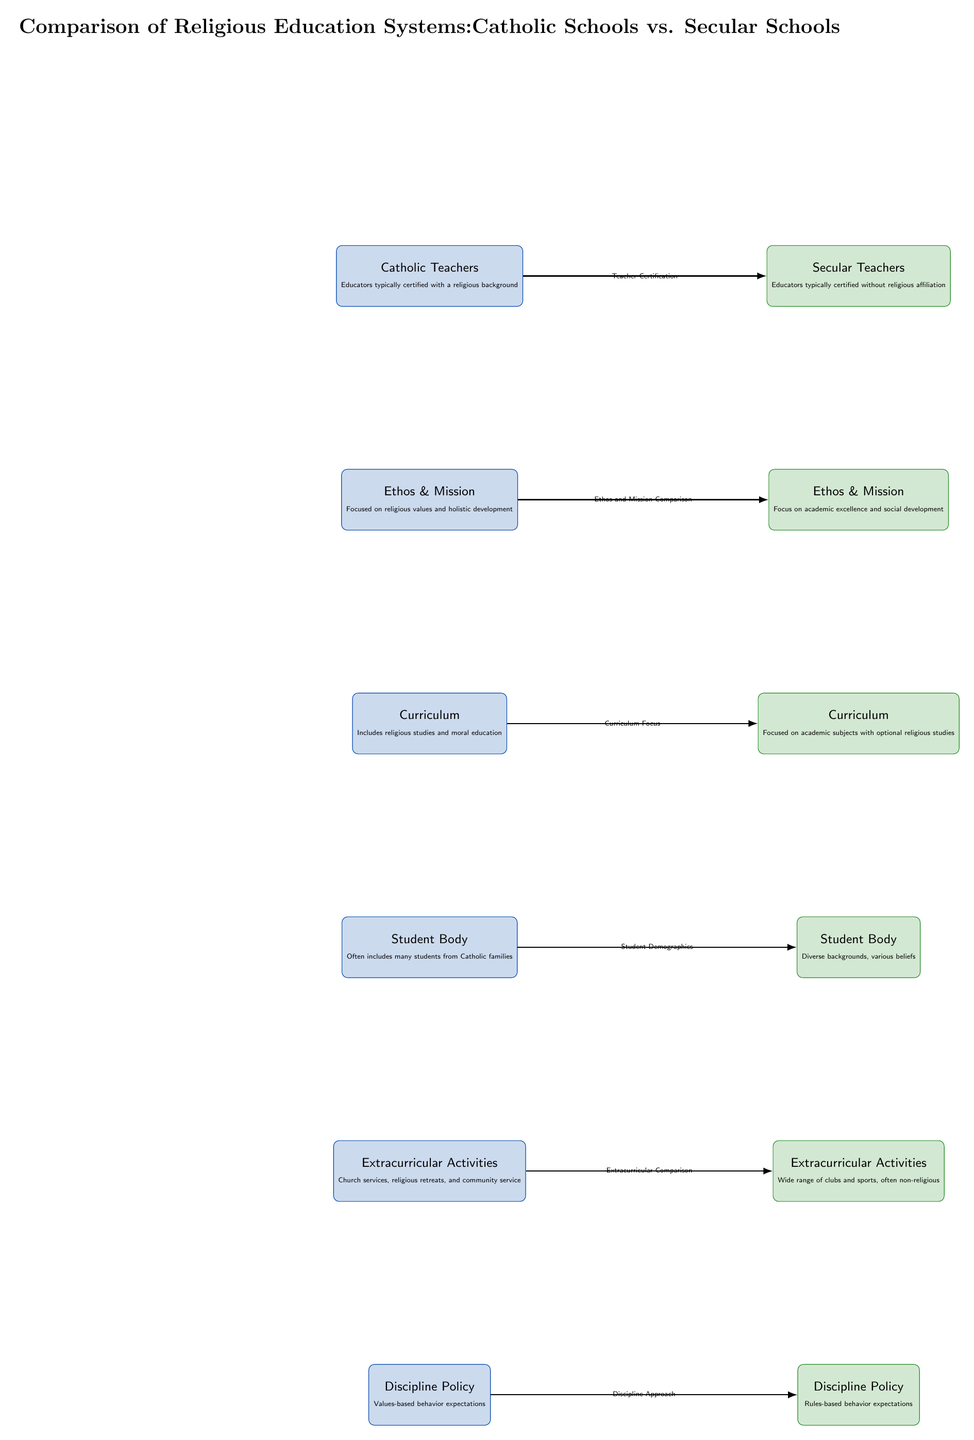What type of teachers are characteristic of Catholic schools? The diagram indicates that Catholic schools typically have teachers with a religious background, as stated in the node labeled "Catholic Teachers."
Answer: Catholic Teachers What is the focus of the curriculum in secular schools? According to the diagram, the curriculum in secular schools is primarily focused on academic subjects, with optional religious studies mentioned in the "Curriculum" node.
Answer: Academic subjects What kind of extracurricular activities are common in Catholic schools? The diagram specifies that Catholic schools offer church services, religious retreats, and community service as part of their extracurricular activities.
Answer: Church services, religious retreats, and community service How do the discipline policies differ between Catholic and secular schools? The diagram shows that Catholic schools implement values-based behavior expectations, while secular schools follow rules-based behavior expectations, indicating a fundamental difference in their discipline policies.
Answer: Values-based vs. rules-based What is the relationship between the ethos and mission of Catholic and secular schools? The diagram illustrates a direct comparison between the ethos and mission of both types of schools, highlighting Catholic schools' focus on religious values and holistic development versus secular schools' focus on academic excellence and social development.
Answer: Ethos and Mission Comparison What is the primary demographic characteristic of the student body in Catholic schools? The diagram indicates that the student body in Catholic schools often includes many students from Catholic families, as described in the "Student Body" node.
Answer: Students from Catholic families How many main comparison categories are present in the diagram? By examining the diagram, we can count six main comparison categories below the title: Teacher Certification, Ethos and Mission Comparison, Curriculum Focus, Student Demographics, Extracurricular Comparison, and Discipline Approach.
Answer: Six What is the difference in teacher certification between the two schools? The diagram shows a distinction in teacher certification, highlighting that Catholic teachers are typically certified with a religious background, contrasted with secular teachers who typically have no religious affiliation.
Answer: Religious vs. non-religious certification What type of background do secular school teachers generally have? According to the diagram, secular school teachers are typically certified without any religious affiliation, as indicated in the "Secular Teachers" node.
Answer: No religious affiliation 